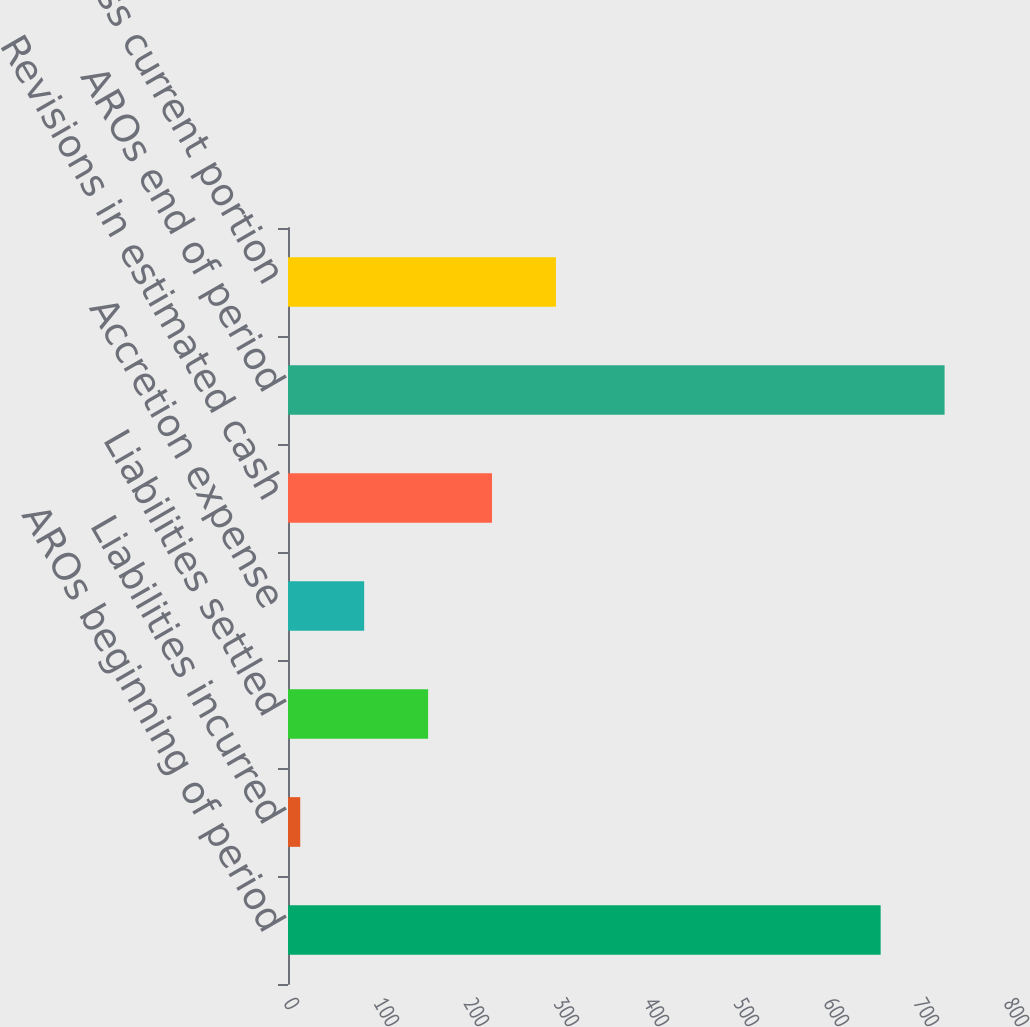Convert chart. <chart><loc_0><loc_0><loc_500><loc_500><bar_chart><fcel>AROs beginning of period<fcel>Liabilities incurred<fcel>Liabilities settled<fcel>Accretion expense<fcel>Revisions in estimated cash<fcel>AROs end of period<fcel>Less current portion<nl><fcel>658.5<fcel>13.6<fcel>155.66<fcel>84.63<fcel>226.69<fcel>729.53<fcel>297.72<nl></chart> 